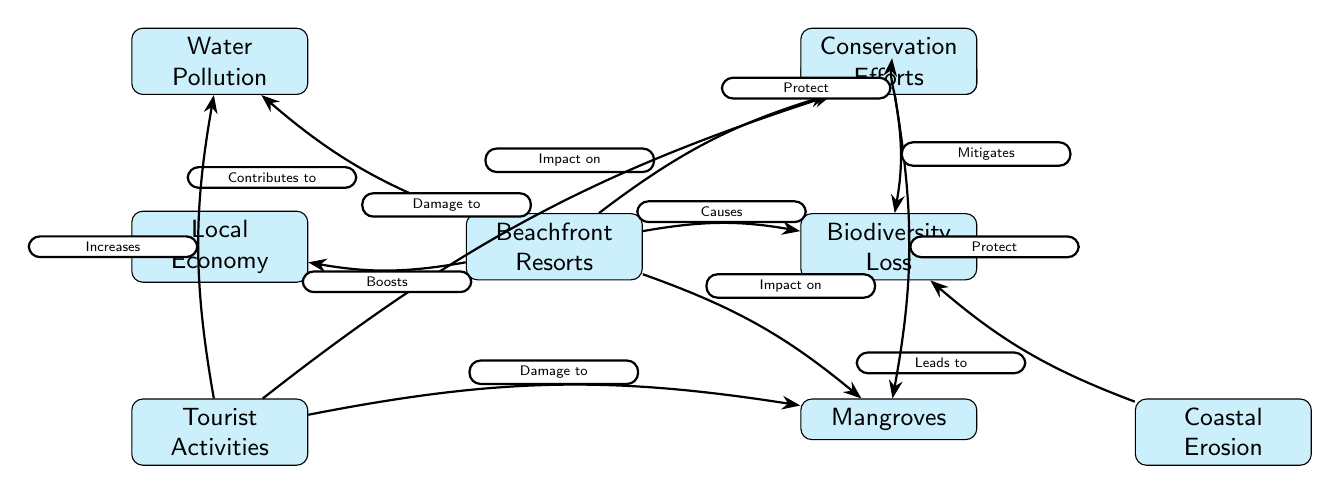What is the main subject of the diagram? The diagram focuses on the "Beachfront Resorts" as the central subject, which connects multiple environmental effects and relationships showcasing their impact on biodiversity.
Answer: Beachfront Resorts How many nodes are there in total? By counting all the distinct elements in the diagram, including the main subject and related environmental factors, there are 8 nodes in total.
Answer: 8 What does "Tourist Activities" damage? "Tourist Activities" leads to damage in both "Coral Reefs" and "Mangroves," as depicted by the arrows pointing from "Tourist Activities" to each of these nodes.
Answer: Coral Reefs and Mangroves What impact do beachfront resorts have on water? "Beachfront Resorts" contribute to "Water Pollution," as indicated by the connecting arrow that signifies this relationship in the diagram.
Answer: Water Pollution What effect does the local economy experience from beachfront resorts? The diagram indicates that "Beachfront Resorts" boost the "Local Economy," showcasing a positive relationship between these two nodes.
Answer: Boosts Which factors lead to biodiversity loss? The contributing factors to "Biodiversity Loss" include "Beachfront Resorts" and "Coastal Erosion," noted by the arrows pointing towards "Biodiversity Loss."
Answer: Beachfront Resorts and Coastal Erosion What protective role do conservation efforts play? "Conservation Efforts" protect both "Coral Reefs" and "Mangroves," as detailed by the arrows leading from "Conservation Efforts" to these nodes, indicating a direct protective relationship.
Answer: Protect How does coastal erosion relate to biodiversity loss? "Coastal Erosion" leads to "Biodiversity Loss," as depicted in the diagram where an arrow indicating a direct consequence links the two nodes.
Answer: Leads to What is increased by tourist activities according to the diagram? The diagram shows that "Tourist Activities" increase "Water Pollution," as signified by the connecting arrow that points to "Water Pollution."
Answer: Increases 